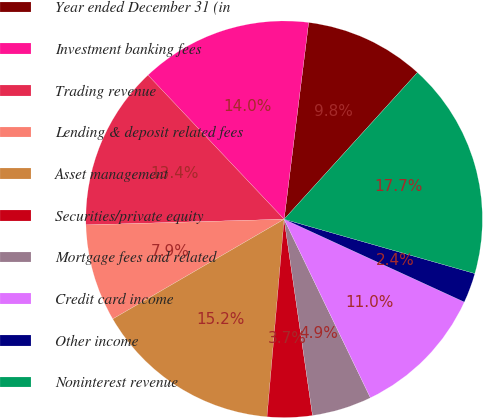Convert chart to OTSL. <chart><loc_0><loc_0><loc_500><loc_500><pie_chart><fcel>Year ended December 31 (in<fcel>Investment banking fees<fcel>Trading revenue<fcel>Lending & deposit related fees<fcel>Asset management<fcel>Securities/private equity<fcel>Mortgage fees and related<fcel>Credit card income<fcel>Other income<fcel>Noninterest revenue<nl><fcel>9.76%<fcel>14.02%<fcel>13.41%<fcel>7.93%<fcel>15.24%<fcel>3.66%<fcel>4.88%<fcel>10.98%<fcel>2.44%<fcel>17.68%<nl></chart> 